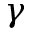Convert formula to latex. <formula><loc_0><loc_0><loc_500><loc_500>\gamma</formula> 